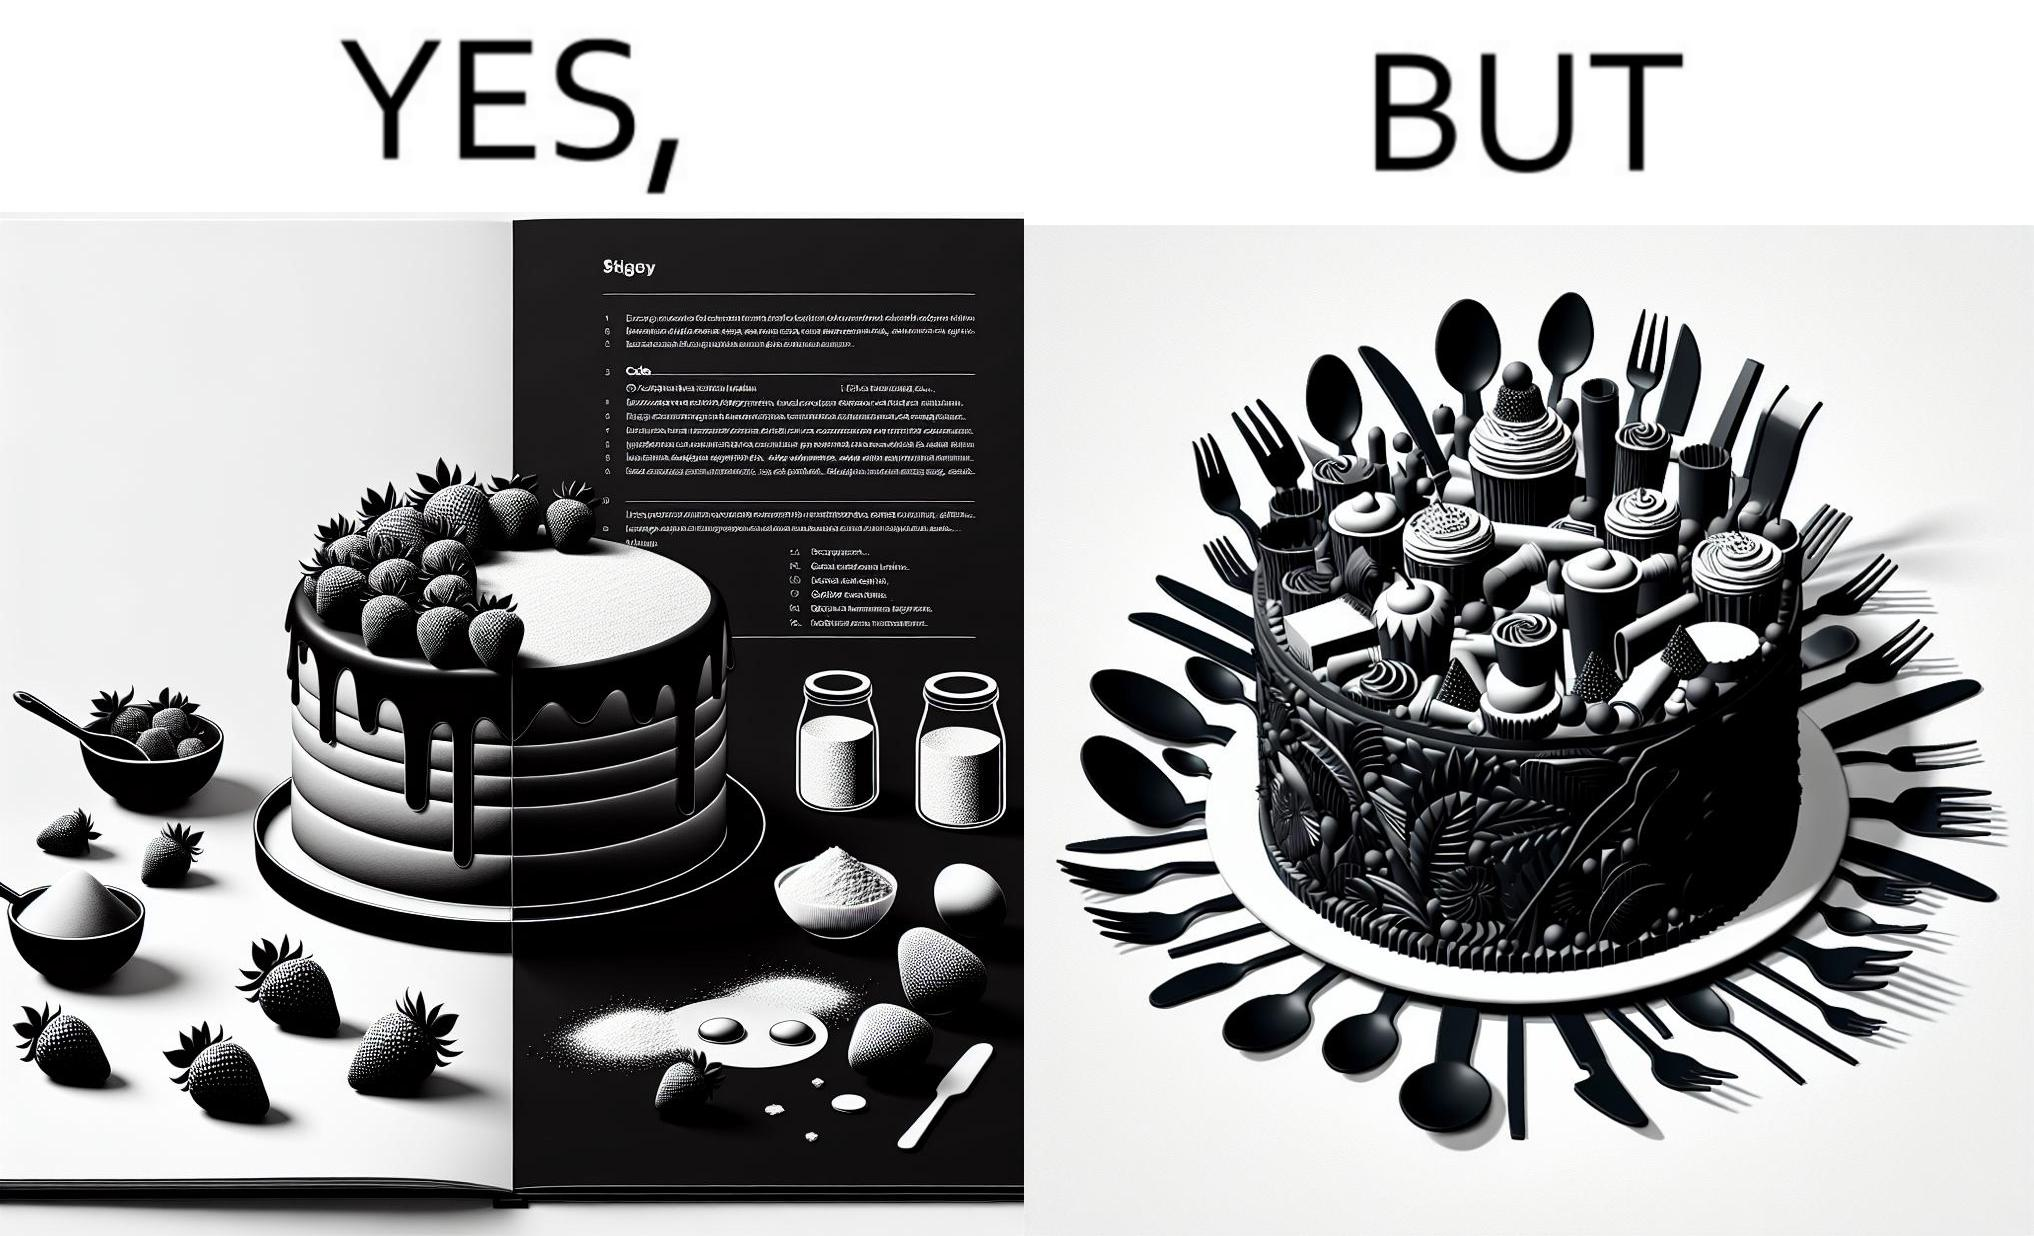Is there satirical content in this image? Yes, this image is satirical. 